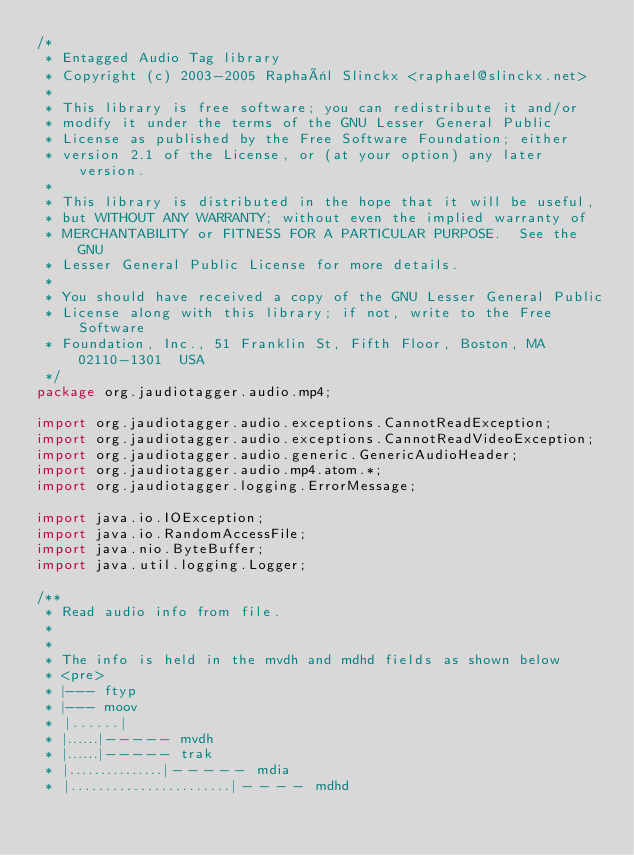Convert code to text. <code><loc_0><loc_0><loc_500><loc_500><_Java_>/*
 * Entagged Audio Tag library
 * Copyright (c) 2003-2005 Raphaël Slinckx <raphael@slinckx.net>
 * 
 * This library is free software; you can redistribute it and/or
 * modify it under the terms of the GNU Lesser General Public
 * License as published by the Free Software Foundation; either
 * version 2.1 of the License, or (at your option) any later version.
 *  
 * This library is distributed in the hope that it will be useful,
 * but WITHOUT ANY WARRANTY; without even the implied warranty of
 * MERCHANTABILITY or FITNESS FOR A PARTICULAR PURPOSE.  See the GNU
 * Lesser General Public License for more details.
 * 
 * You should have received a copy of the GNU Lesser General Public
 * License along with this library; if not, write to the Free Software
 * Foundation, Inc., 51 Franklin St, Fifth Floor, Boston, MA  02110-1301  USA
 */
package org.jaudiotagger.audio.mp4;

import org.jaudiotagger.audio.exceptions.CannotReadException;
import org.jaudiotagger.audio.exceptions.CannotReadVideoException;
import org.jaudiotagger.audio.generic.GenericAudioHeader;
import org.jaudiotagger.audio.mp4.atom.*;
import org.jaudiotagger.logging.ErrorMessage;

import java.io.IOException;
import java.io.RandomAccessFile;
import java.nio.ByteBuffer;
import java.util.logging.Logger;

/**
 * Read audio info from file.
 *
 *
 * The info is held in the mvdh and mdhd fields as shown below
 * <pre>
 * |--- ftyp
 * |--- moov
 * |......|
 * |......|----- mvdh
 * |......|----- trak
 * |...............|----- mdia
 * |.......................|---- mdhd</code> 